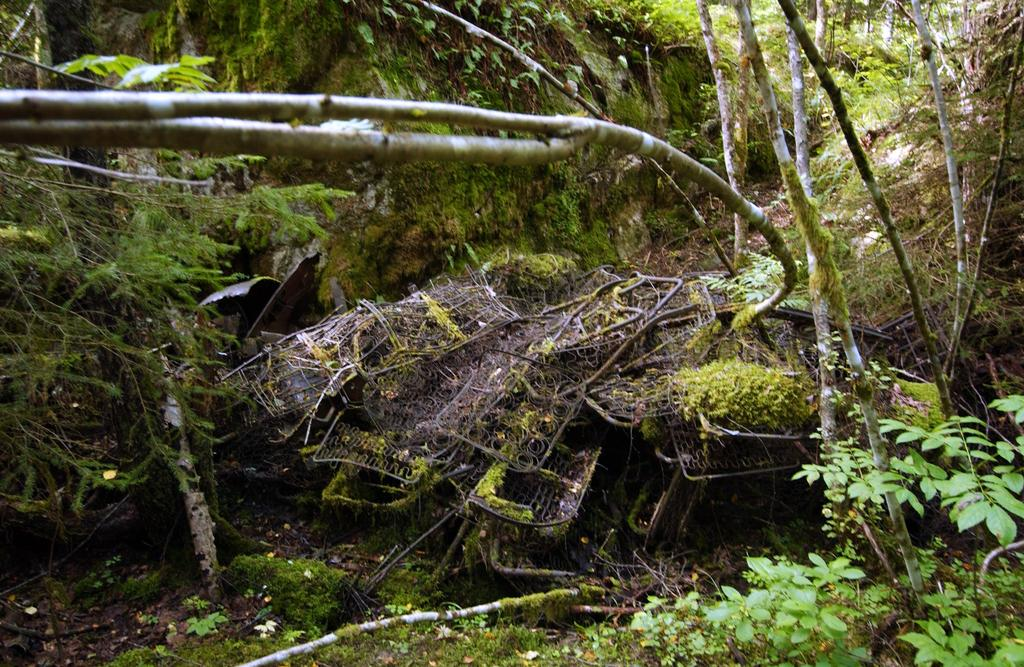What type of vegetation is visible in the image? There is grass, plants, and trees visible in the image. Can you describe the natural environment in the image? The natural environment in the image includes grass, plants, and trees. What type of plants can be seen in the image? The plants in the image are not specified, but they are present alongside grass and trees. What is the income of the chicken in the image? There is no chicken present in the image, so it is not possible to determine its income. 